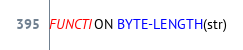Convert code to text. <code><loc_0><loc_0><loc_500><loc_500><_COBOL_>FUNCTION BYTE-LENGTH(str)
</code> 